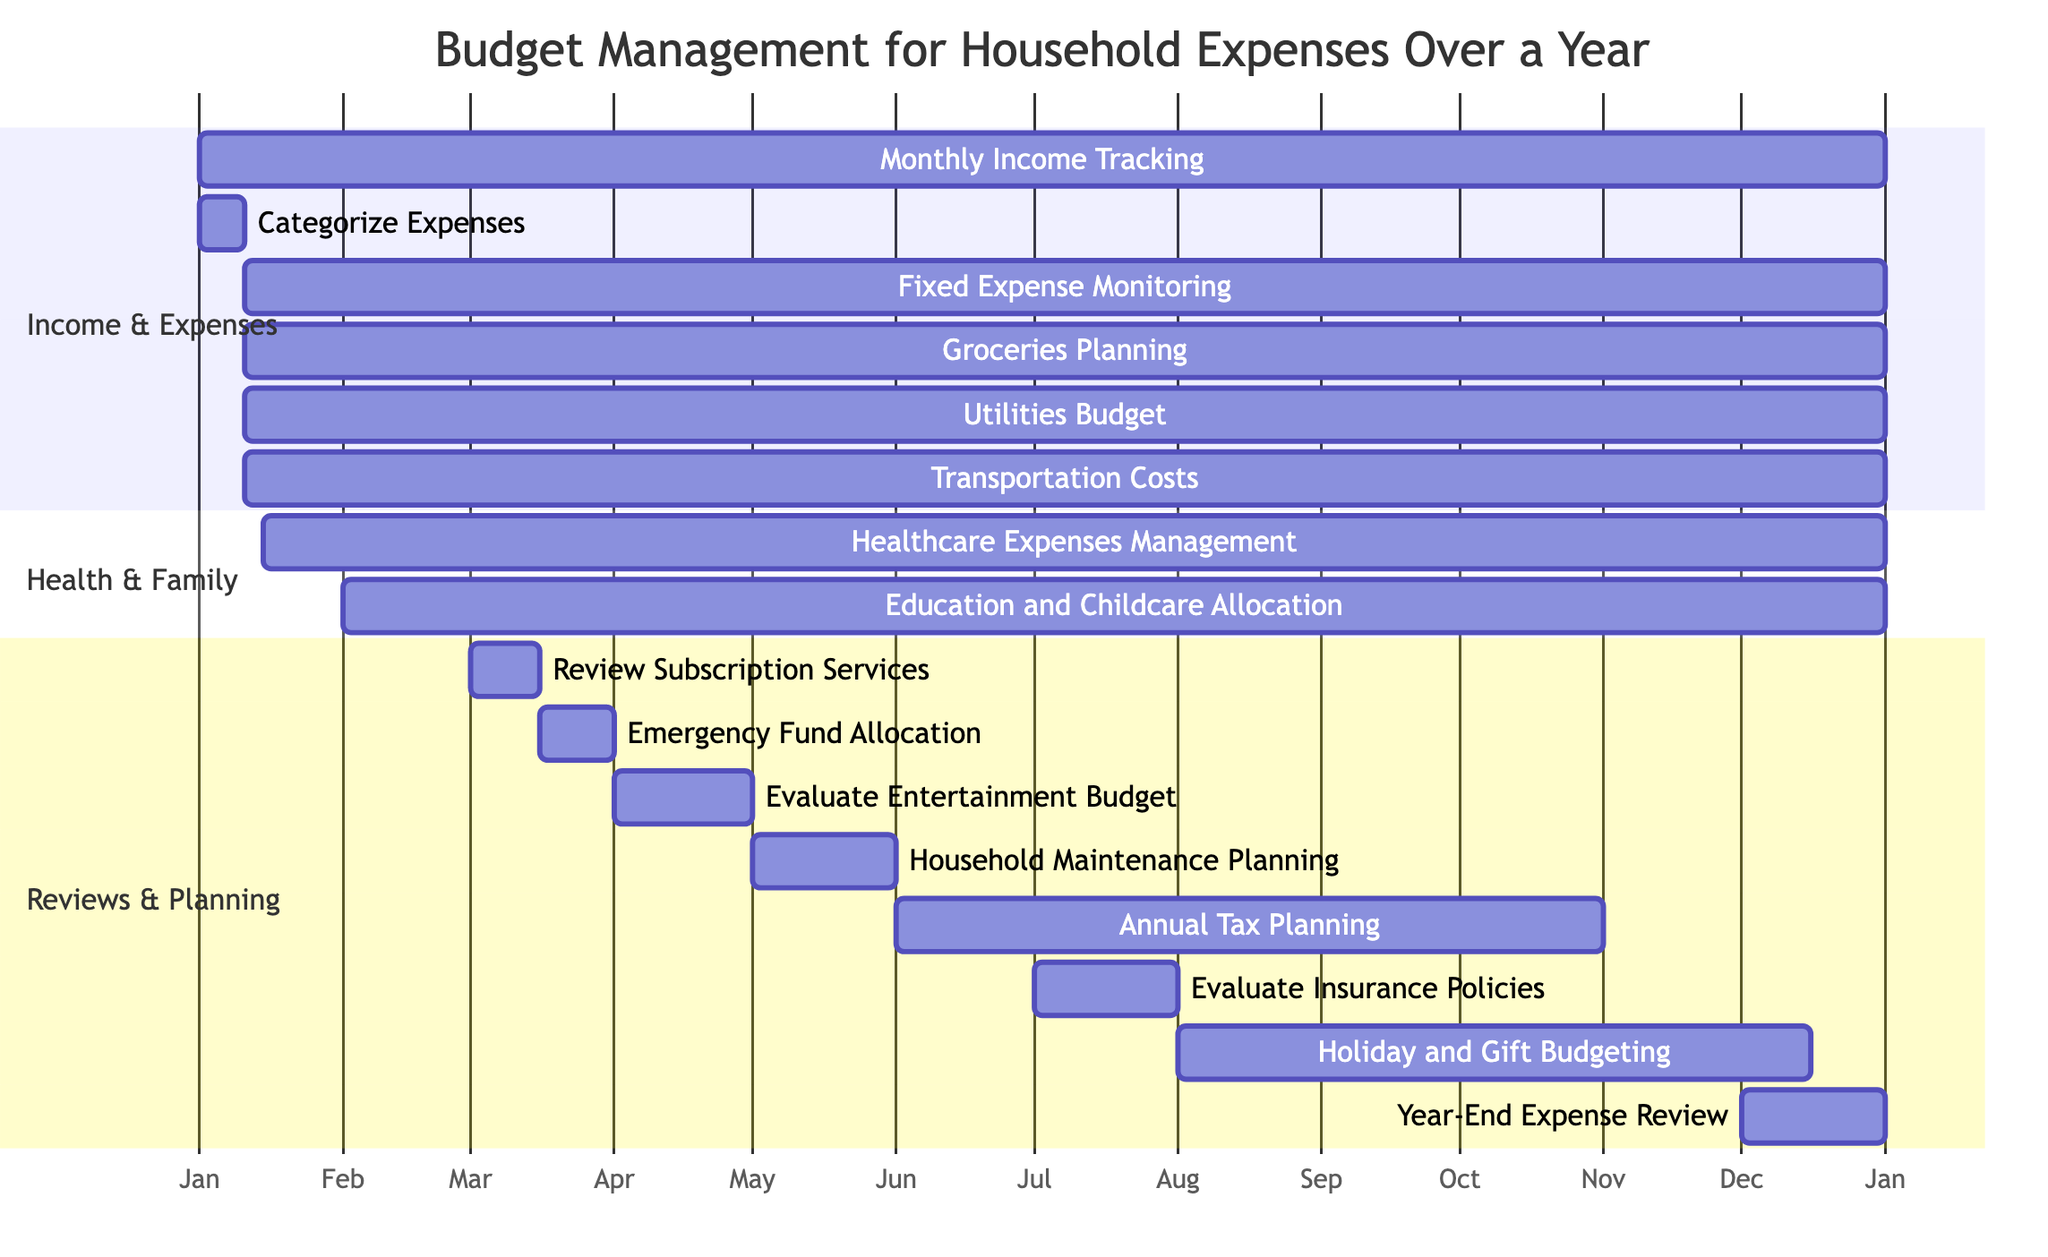What's the total number of tasks in the diagram? The diagram lists all tasks under different sections. By counting the tasks, we find there are 16 separate tasks listed.
Answer: 16 What is the duration of the "Categorize Expenses" task? The task "Categorize Expenses" starts on January 1, 2023, and ends on January 10, 2023. The duration is 10 days.
Answer: 10 days Which task starts on March 1, 2023? By checking the tasks, we see that "Review Subscription Services" begins on March 1, 2023.
Answer: Review Subscription Services Which tasks overlap with "Fixed Expense Monitoring"? "Fixed Expense Monitoring" runs from January 11, 2023, to December 31, 2023. The overlapping tasks are "Groceries Planning," "Utilities Budget," "Transportation Costs," and "Healthcare Expenses Management."
Answer: Groceries Planning, Utilities Budget, Transportation Costs, Healthcare Expenses Management How many days does the "Holiday and Gift Budgeting" task last? The task "Holiday and Gift Budgeting" starts on August 1, 2023, and ends on December 15, 2023. To calculate the duration, we count the days, resulting in 137 days.
Answer: 137 days Which task ends last in the year? By analyzing the ending dates, we note that "Monthly Income Tracking" and "Year-End Expense Review" both end on December 31, 2023, making them the last tasks of the year.
Answer: Monthly Income Tracking, Year-End Expense Review Which section has the most tasks? When reviewing the diagram, the "Income & Expenses" section has five tasks. Thus, it has the most tasks compared to the other sections.
Answer: Income & Expenses What is the main focus of the section titled "Health & Family"? By examining the tasks listed under "Health & Family," we see that it revolves around healthcare and educational expenses, specifically "Healthcare Expenses Management" and "Education and Childcare Allocation."
Answer: Healthcare and Education What is the relationship between "Emergency Fund Allocation" and "Review Subscription Services"? There is no direct relation between these two tasks, as the former starts on March 16 and the latter ends on March 15, meaning they do not overlap in time.
Answer: No direct relation 